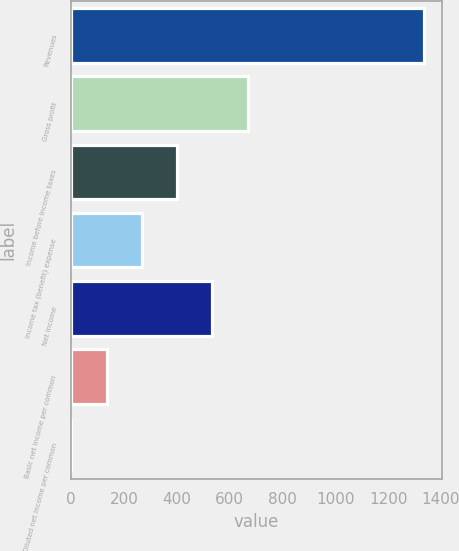<chart> <loc_0><loc_0><loc_500><loc_500><bar_chart><fcel>Revenues<fcel>Gross profit<fcel>Income before income taxes<fcel>Income tax (benefit) expense<fcel>Net income<fcel>Basic net income per common<fcel>Diluted net income per common<nl><fcel>1336.2<fcel>668.25<fcel>401.07<fcel>267.48<fcel>534.66<fcel>133.89<fcel>0.3<nl></chart> 